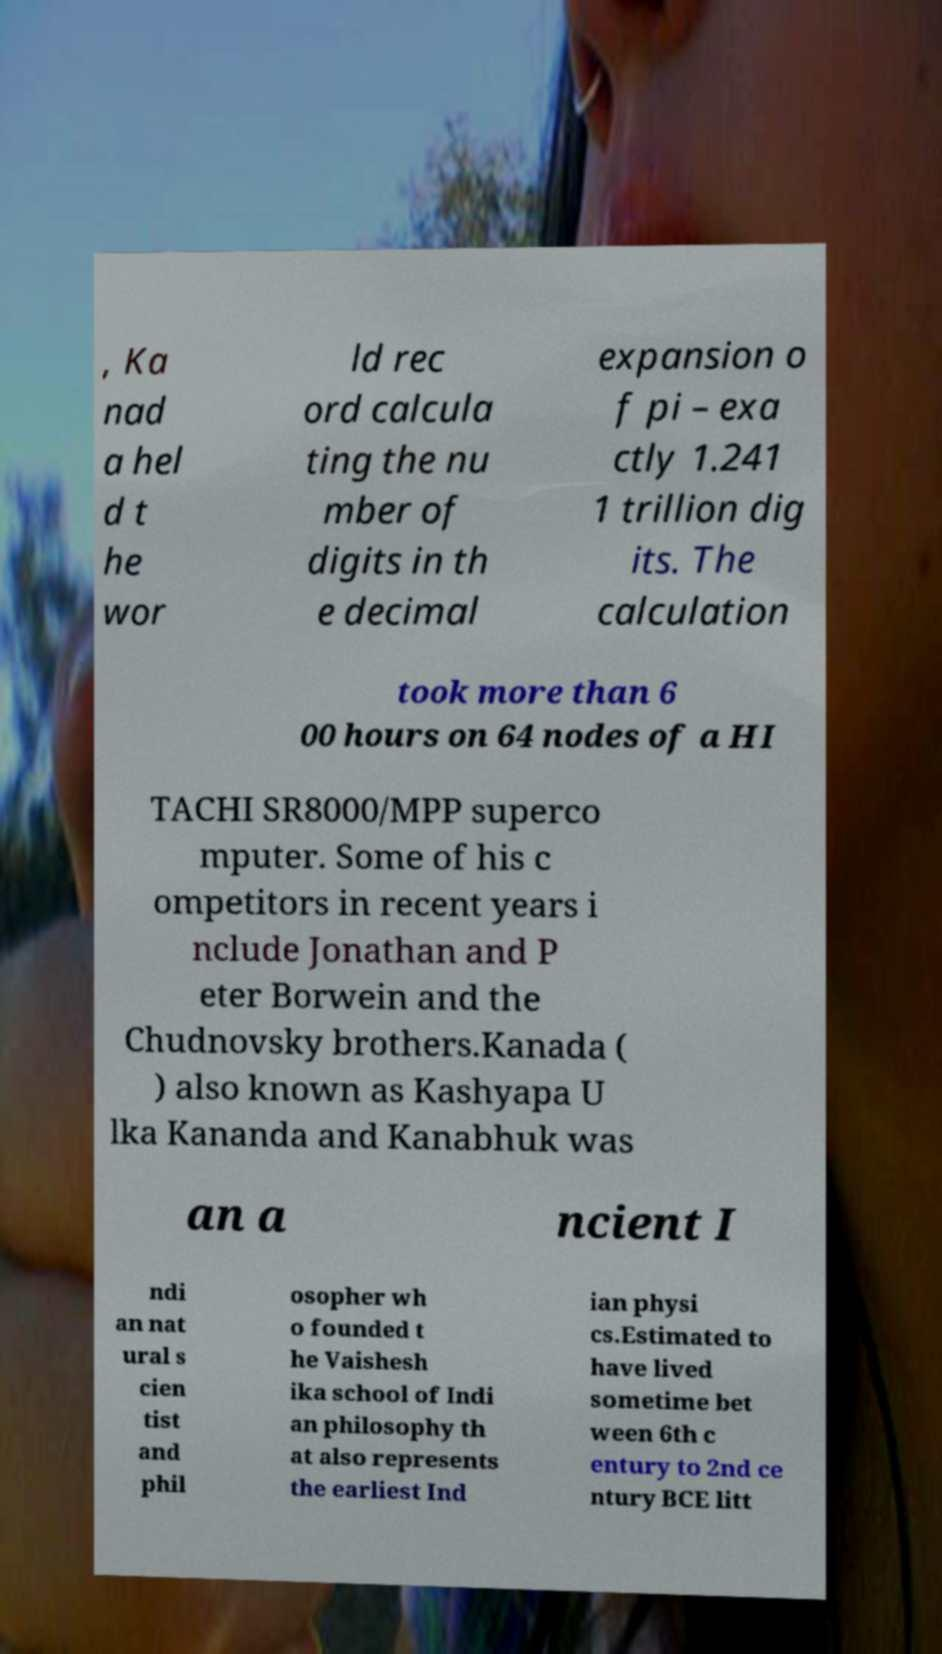For documentation purposes, I need the text within this image transcribed. Could you provide that? , Ka nad a hel d t he wor ld rec ord calcula ting the nu mber of digits in th e decimal expansion o f pi – exa ctly 1.241 1 trillion dig its. The calculation took more than 6 00 hours on 64 nodes of a HI TACHI SR8000/MPP superco mputer. Some of his c ompetitors in recent years i nclude Jonathan and P eter Borwein and the Chudnovsky brothers.Kanada ( ) also known as Kashyapa U lka Kananda and Kanabhuk was an a ncient I ndi an nat ural s cien tist and phil osopher wh o founded t he Vaishesh ika school of Indi an philosophy th at also represents the earliest Ind ian physi cs.Estimated to have lived sometime bet ween 6th c entury to 2nd ce ntury BCE litt 